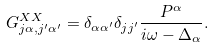Convert formula to latex. <formula><loc_0><loc_0><loc_500><loc_500>G _ { j \alpha , j ^ { \prime } \alpha ^ { \prime } } ^ { X X } = \delta _ { \alpha \alpha ^ { \prime } } \delta _ { j j ^ { \prime } } \frac { P ^ { \alpha } } { i \omega - \Delta _ { \alpha } } .</formula> 